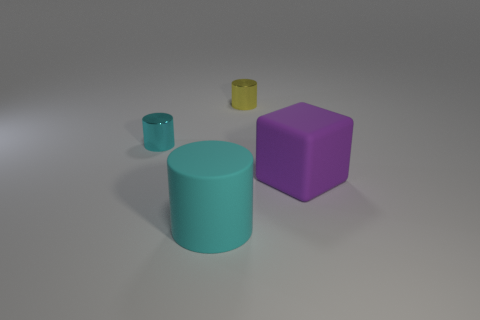How many cyan objects are both behind the big purple cube and in front of the matte cube?
Your response must be concise. 0. Is there anything else that has the same color as the rubber cube?
Make the answer very short. No. What number of matte objects are small yellow things or small cylinders?
Your answer should be very brief. 0. There is a small cylinder that is in front of the tiny cylinder right of the rubber thing that is in front of the purple thing; what is its material?
Your response must be concise. Metal. There is a large object that is to the left of the large purple matte block that is right of the cyan metallic cylinder; what is it made of?
Your answer should be very brief. Rubber. Is the size of the object right of the tiny yellow cylinder the same as the cyan object that is in front of the purple rubber object?
Your answer should be compact. Yes. Is there anything else that is the same material as the cube?
Give a very brief answer. Yes. What number of tiny objects are either purple rubber things or red spheres?
Provide a short and direct response. 0. How many things are either objects on the right side of the small cyan metal object or tiny metallic things?
Keep it short and to the point. 4. Do the large matte cylinder and the cube have the same color?
Offer a terse response. No. 